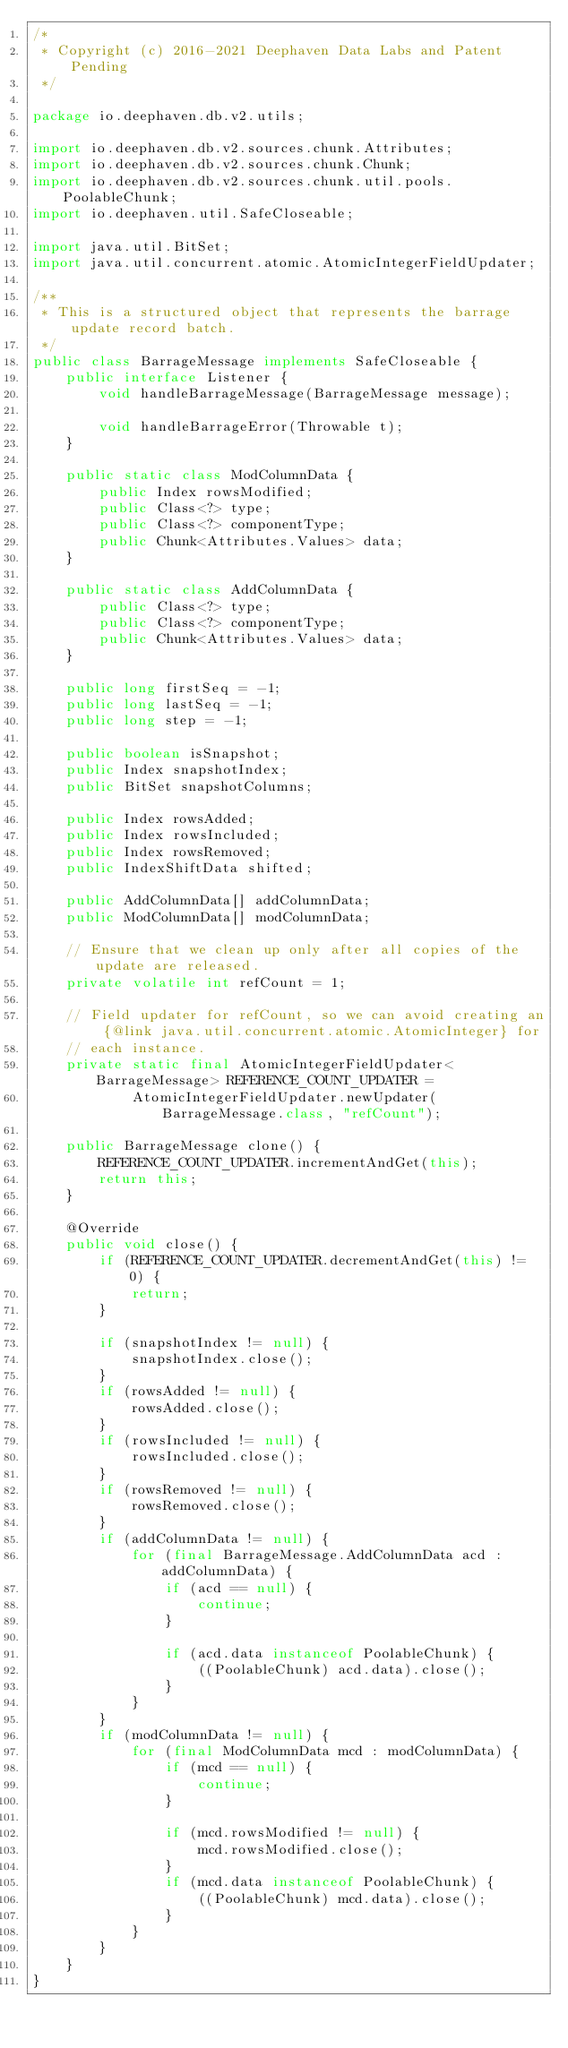Convert code to text. <code><loc_0><loc_0><loc_500><loc_500><_Java_>/*
 * Copyright (c) 2016-2021 Deephaven Data Labs and Patent Pending
 */

package io.deephaven.db.v2.utils;

import io.deephaven.db.v2.sources.chunk.Attributes;
import io.deephaven.db.v2.sources.chunk.Chunk;
import io.deephaven.db.v2.sources.chunk.util.pools.PoolableChunk;
import io.deephaven.util.SafeCloseable;

import java.util.BitSet;
import java.util.concurrent.atomic.AtomicIntegerFieldUpdater;

/**
 * This is a structured object that represents the barrage update record batch.
 */
public class BarrageMessage implements SafeCloseable {
    public interface Listener {
        void handleBarrageMessage(BarrageMessage message);

        void handleBarrageError(Throwable t);
    }

    public static class ModColumnData {
        public Index rowsModified;
        public Class<?> type;
        public Class<?> componentType;
        public Chunk<Attributes.Values> data;
    }

    public static class AddColumnData {
        public Class<?> type;
        public Class<?> componentType;
        public Chunk<Attributes.Values> data;
    }

    public long firstSeq = -1;
    public long lastSeq = -1;
    public long step = -1;

    public boolean isSnapshot;
    public Index snapshotIndex;
    public BitSet snapshotColumns;

    public Index rowsAdded;
    public Index rowsIncluded;
    public Index rowsRemoved;
    public IndexShiftData shifted;

    public AddColumnData[] addColumnData;
    public ModColumnData[] modColumnData;

    // Ensure that we clean up only after all copies of the update are released.
    private volatile int refCount = 1;

    // Field updater for refCount, so we can avoid creating an {@link java.util.concurrent.atomic.AtomicInteger} for
    // each instance.
    private static final AtomicIntegerFieldUpdater<BarrageMessage> REFERENCE_COUNT_UPDATER =
            AtomicIntegerFieldUpdater.newUpdater(BarrageMessage.class, "refCount");

    public BarrageMessage clone() {
        REFERENCE_COUNT_UPDATER.incrementAndGet(this);
        return this;
    }

    @Override
    public void close() {
        if (REFERENCE_COUNT_UPDATER.decrementAndGet(this) != 0) {
            return;
        }

        if (snapshotIndex != null) {
            snapshotIndex.close();
        }
        if (rowsAdded != null) {
            rowsAdded.close();
        }
        if (rowsIncluded != null) {
            rowsIncluded.close();
        }
        if (rowsRemoved != null) {
            rowsRemoved.close();
        }
        if (addColumnData != null) {
            for (final BarrageMessage.AddColumnData acd : addColumnData) {
                if (acd == null) {
                    continue;
                }

                if (acd.data instanceof PoolableChunk) {
                    ((PoolableChunk) acd.data).close();
                }
            }
        }
        if (modColumnData != null) {
            for (final ModColumnData mcd : modColumnData) {
                if (mcd == null) {
                    continue;
                }

                if (mcd.rowsModified != null) {
                    mcd.rowsModified.close();
                }
                if (mcd.data instanceof PoolableChunk) {
                    ((PoolableChunk) mcd.data).close();
                }
            }
        }
    }
}
</code> 